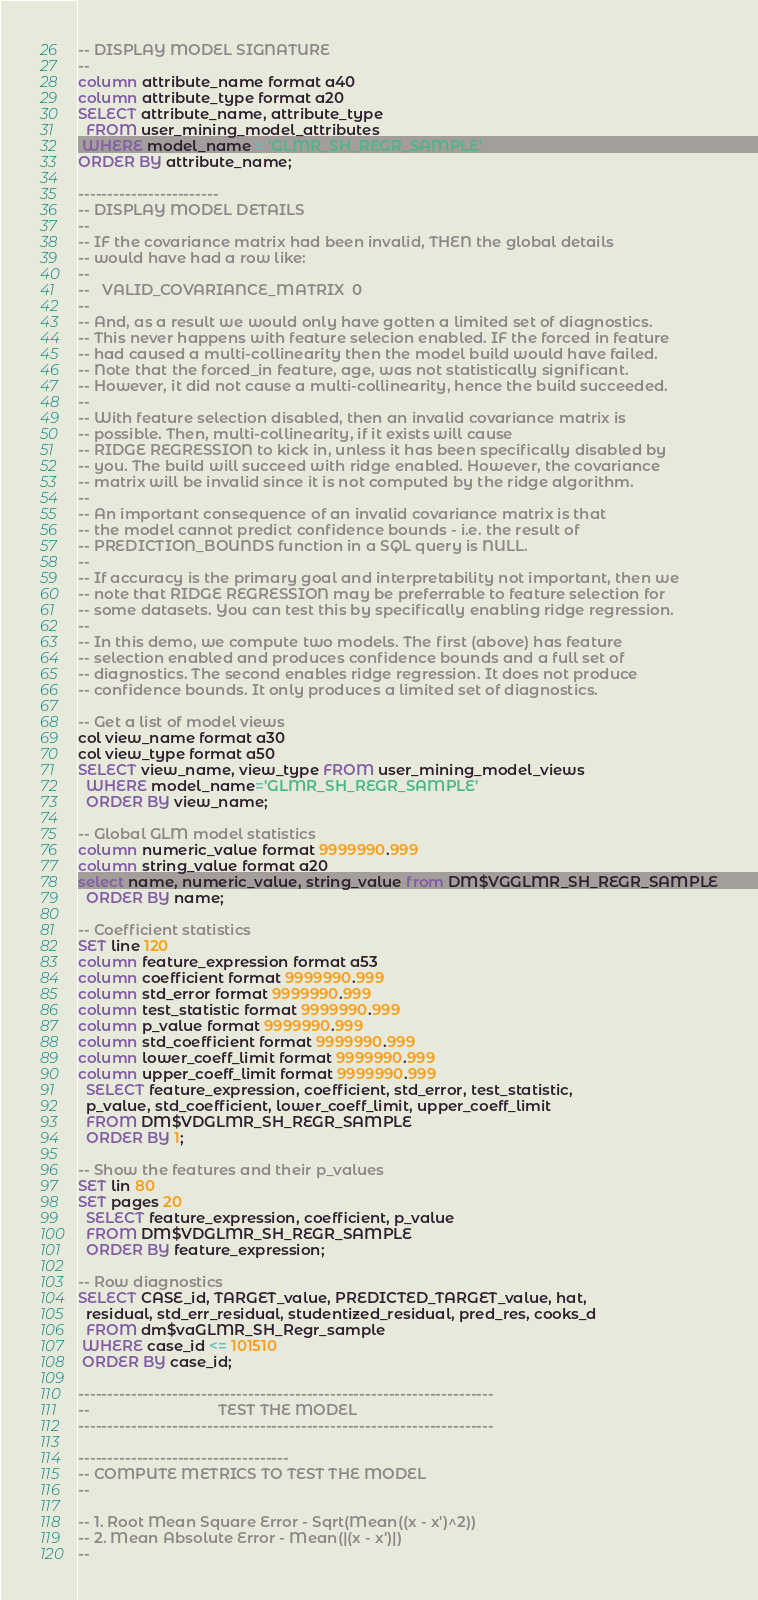<code> <loc_0><loc_0><loc_500><loc_500><_SQL_>-- DISPLAY MODEL SIGNATURE
--
column attribute_name format a40
column attribute_type format a20
SELECT attribute_name, attribute_type
  FROM user_mining_model_attributes
 WHERE model_name = 'GLMR_SH_REGR_SAMPLE'
ORDER BY attribute_name;

------------------------
-- DISPLAY MODEL DETAILS
--
-- IF the covariance matrix had been invalid, THEN the global details 
-- would have had a row like:
--
--   VALID_COVARIANCE_MATRIX  0 
-- 
-- And, as a result we would only have gotten a limited set of diagnostics.
-- This never happens with feature selecion enabled. IF the forced in feature 
-- had caused a multi-collinearity then the model build would have failed.
-- Note that the forced_in feature, age, was not statistically significant.
-- However, it did not cause a multi-collinearity, hence the build succeeded.
--
-- With feature selection disabled, then an invalid covariance matrix is 
-- possible. Then, multi-collinearity, if it exists will cause 
-- RIDGE REGRESSION to kick in, unless it has been specifically disabled by 
-- you. The build will succeed with ridge enabled. However, the covariance 
-- matrix will be invalid since it is not computed by the ridge algorithm.
-- 
-- An important consequence of an invalid covariance matrix is that
-- the model cannot predict confidence bounds - i.e. the result of
-- PREDICTION_BOUNDS function in a SQL query is NULL.
--
-- If accuracy is the primary goal and interpretability not important, then we
-- note that RIDGE REGRESSION may be preferrable to feature selection for 
-- some datasets. You can test this by specifically enabling ridge regression.
-- 
-- In this demo, we compute two models. The first (above) has feature
-- selection enabled and produces confidence bounds and a full set of 
-- diagnostics. The second enables ridge regression. It does not produce 
-- confidence bounds. It only produces a limited set of diagnostics.

-- Get a list of model views
col view_name format a30
col view_type format a50
SELECT view_name, view_type FROM user_mining_model_views
  WHERE model_name='GLMR_SH_REGR_SAMPLE'
  ORDER BY view_name;

-- Global GLM model statistics
column numeric_value format 9999990.999
column string_value format a20
select name, numeric_value, string_value from DM$VGGLMR_SH_REGR_SAMPLE
  ORDER BY name;

-- Coefficient statistics
SET line 120
column feature_expression format a53 
column coefficient format 9999990.999
column std_error format 9999990.999 
column test_statistic format 9999990.999  
column p_value format 9999990.999  
column std_coefficient format 9999990.999  
column lower_coeff_limit format 9999990.999 
column upper_coeff_limit format 9999990.999  
  SELECT feature_expression, coefficient, std_error, test_statistic,
  p_value, std_coefficient, lower_coeff_limit, upper_coeff_limit
  FROM DM$VDGLMR_SH_REGR_SAMPLE
  ORDER BY 1;

-- Show the features and their p_values
SET lin 80
SET pages 20
  SELECT feature_expression, coefficient, p_value 
  FROM DM$VDGLMR_SH_REGR_SAMPLE
  ORDER BY feature_expression;

-- Row diagnostics
SELECT CASE_id, TARGET_value, PREDICTED_TARGET_value, hat, 
  residual, std_err_residual, studentized_residual, pred_res, cooks_d
  FROM dm$vaGLMR_SH_Regr_sample
 WHERE case_id <= 101510
 ORDER BY case_id;

-----------------------------------------------------------------------
--                               TEST THE MODEL
-----------------------------------------------------------------------

------------------------------------
-- COMPUTE METRICS TO TEST THE MODEL
--

-- 1. Root Mean Square Error - Sqrt(Mean((x - x')^2))
-- 2. Mean Absolute Error - Mean(|(x - x')|)
--</code> 